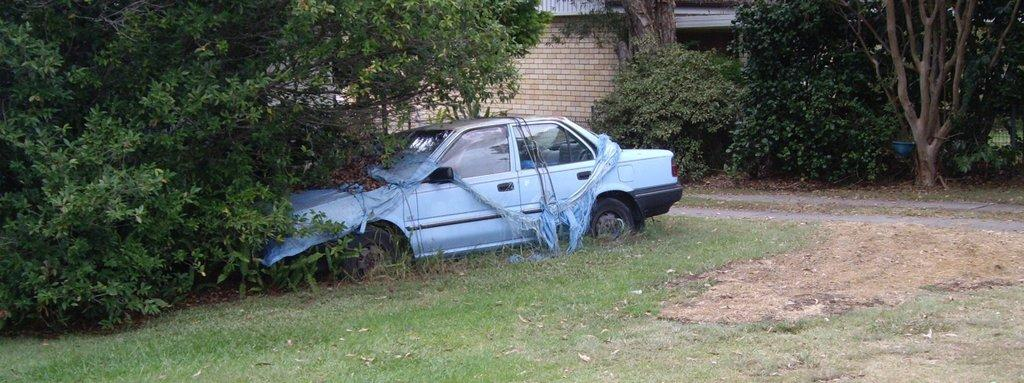What type of structure is visible in the image? There is a building in the image. What other natural elements can be seen in the image? There are trees in the image. Is there any transportation visible in the image? Yes, there is a car in the image. What type of ground surface is present in the image? Grass is present on the ground in the image. What type of metal is the dad using to sign the agreement in the image? There is no dad, metal, or agreement present in the image. 